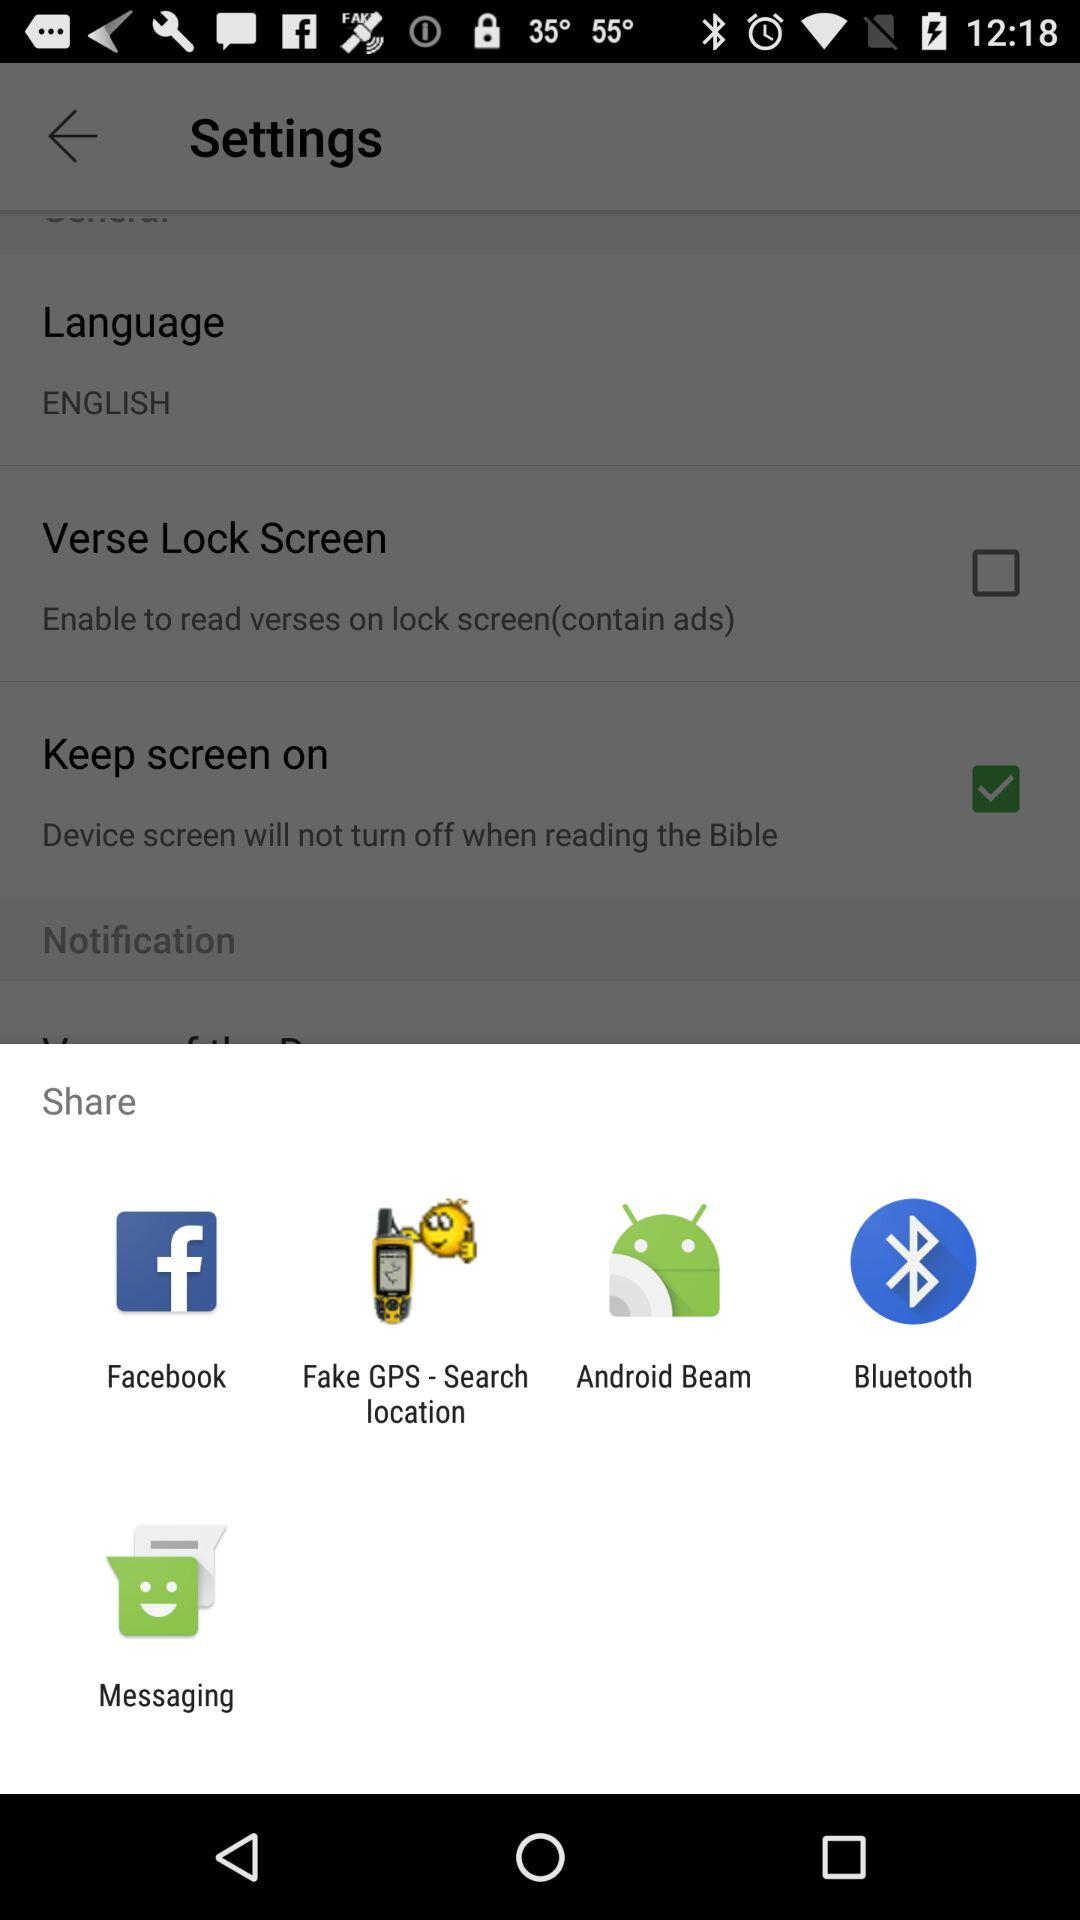How many items in the Settings menu have a checkbox?
Answer the question using a single word or phrase. 2 